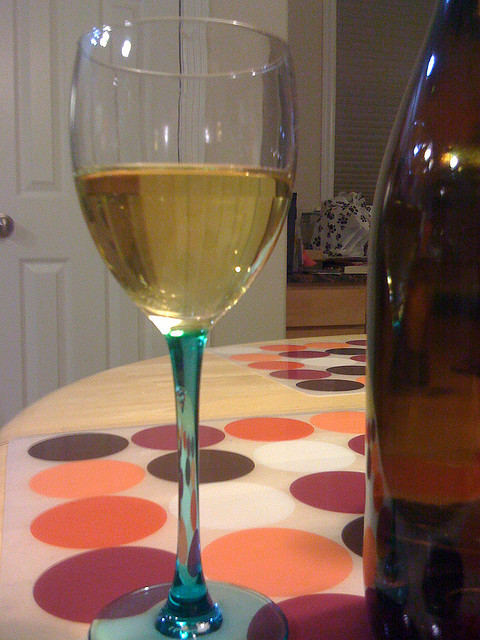<image>What is holding the wine glasses? It is ambiguous what is holding the wine glasses. It might be a table. What is holding the wine glasses? The wine glasses are being held by the table. 